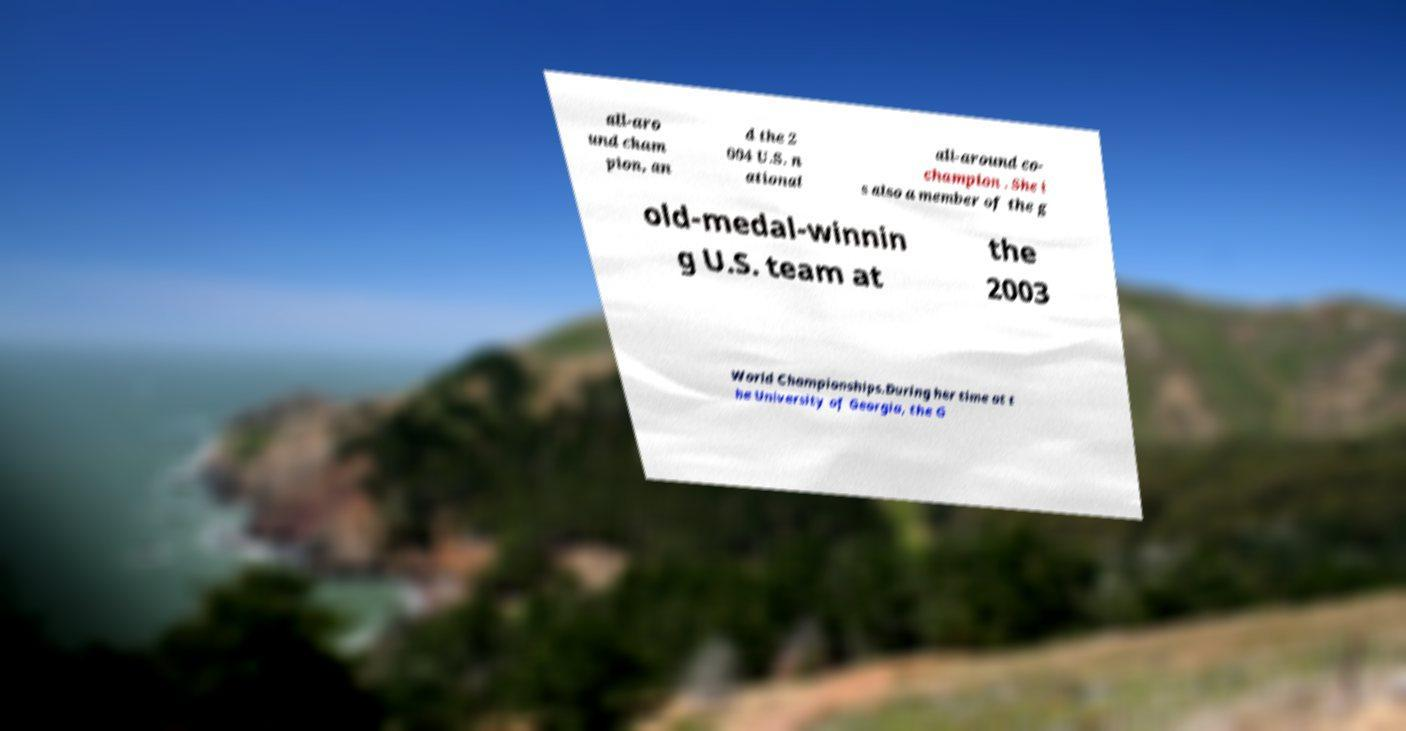Can you read and provide the text displayed in the image?This photo seems to have some interesting text. Can you extract and type it out for me? all-aro und cham pion, an d the 2 004 U.S. n ational all-around co- champion . She i s also a member of the g old-medal-winnin g U.S. team at the 2003 World Championships.During her time at t he University of Georgia, the G 